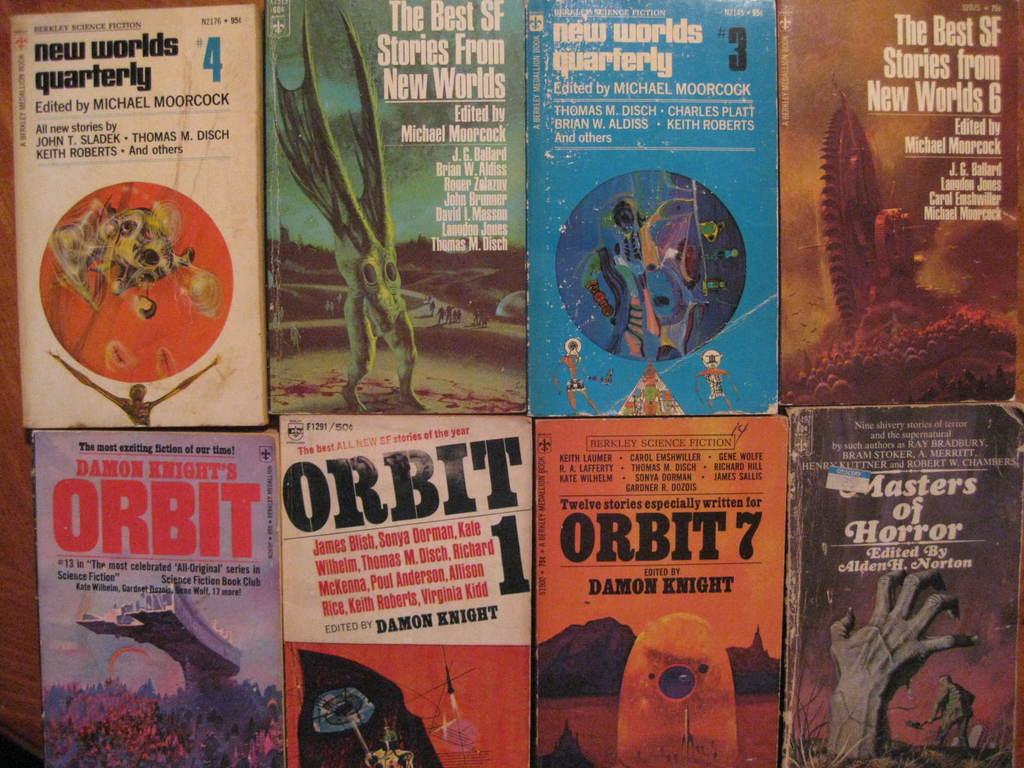Who wrote orbit 7?
Make the answer very short. Damon knight. 